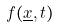<formula> <loc_0><loc_0><loc_500><loc_500>f ( \underline { x } , t )</formula> 